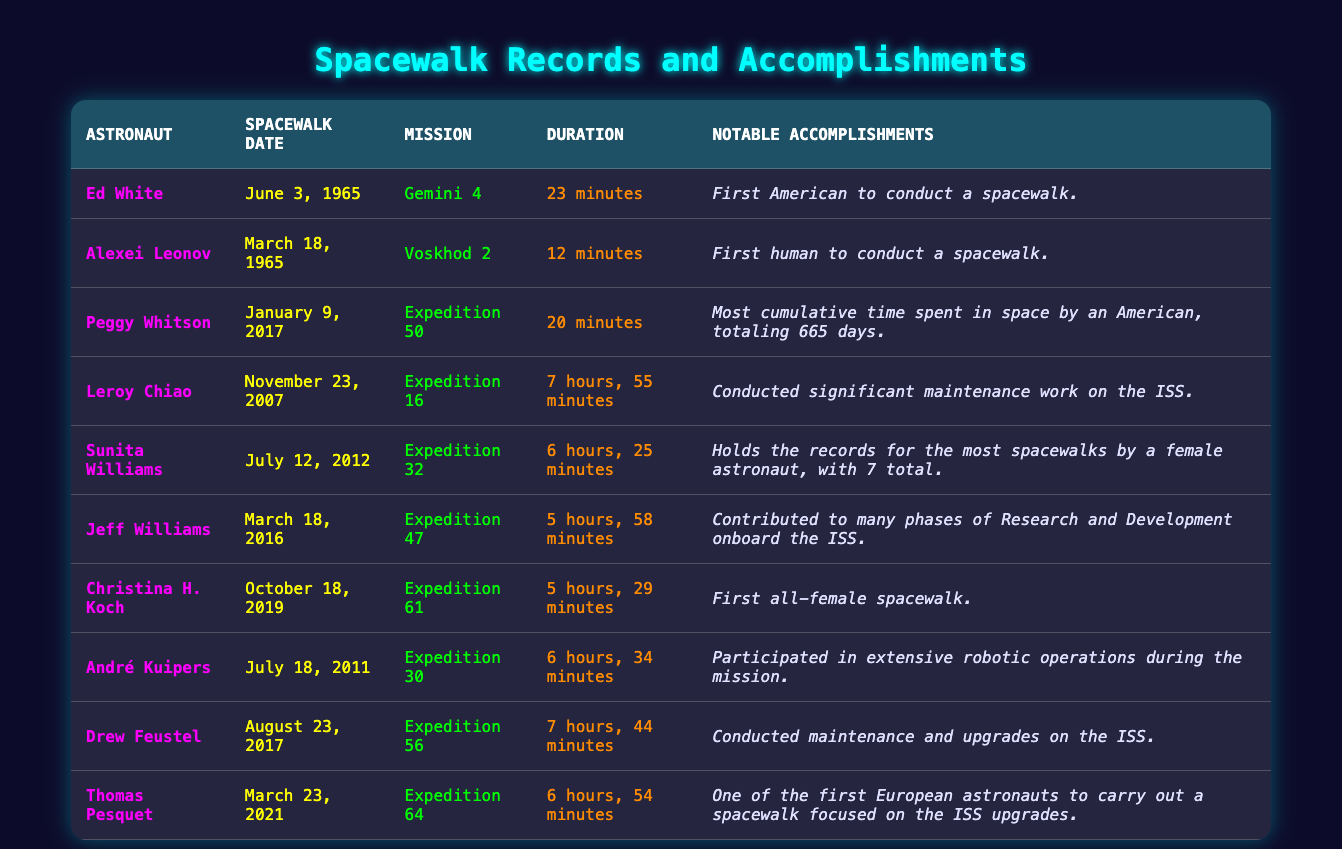What was the duration of Ed White's spacewalk? The table shows that Ed White conducted a spacewalk on June 3, 1965, during the Gemini 4 mission, and the duration of that spacewalk was 23 minutes.
Answer: 23 minutes Who conducted the first human spacewalk? According to the table, Alexei Leonov conducted the first human spacewalk on March 18, 1965, during the Voskhod 2 mission.
Answer: Alexei Leonov How many total hours did Sunita Williams spend on her spacewalks? Sunita Williams conducted a spacewalk lasting 6 hours and 25 minutes. As she holds the record for the most spacewalks by a female astronaut with 7 total, to find the total, we would need additional data on the durations of her other spacewalks, which is not provided in this table. Thus, the information is insufficient to calculate the total.
Answer: Insufficient data Is it true that Christina H. Koch participated in the first all-female spacewalk? The table states that Christina H. Koch's spacewalk on October 18, 2019, was indeed the first all-female spacewalk, confirming that the statement is true.
Answer: True Who has the longest single spacewalk duration listed in the table? By comparing the durations provided, Leroy Chiao’s spacewalk lasted 7 hours and 55 minutes, which is longer than any other listed spacewalk duration.
Answer: Leroy Chiao What is the average duration of the spacewalks conducted by astronauts in the table? To find the average, we first convert all durations to minutes: Ed White (23), Alexei Leonov (12), Peggy Whitson (20), Leroy Chiao (475), Sunita Williams (385), Jeff Williams (358), Christina H. Koch (329), André Kuipers (394), Drew Feustel (464), and Thomas Pesquet (414). Adding these gives a total of 2389 minutes and dividing by 10 (the number of astronauts) gives an average of 238.9 minutes.
Answer: 238.9 minutes Which mission had the shortest spacewalk duration? Looking through the table, Alexei Leonov conducted a spacewalk during the Voskhod 2 mission lasting only 12 minutes, which is the shortest listed duration.
Answer: Voskhod 2 How many astronauts participated in spacewalks longer than 6 hours? The table lists astronauts who completed spacewalks longer than 6 hours: Leroy Chiao (7 hours, 55 minutes), Sunita Williams (6 hours, 25 minutes), Drew Feustel (7 hours, 44 minutes), and André Kuipers (6 hours, 34 minutes). This totals to 4 astronauts.
Answer: 4 astronauts Was Peggy Whitson’s spacewalk notable for spending cumulative time in space? The table indicates that Peggy Whitson’s spacewalk was not just about the duration but is notable for her record of the most cumulative time spent in space as an American, which totals 665 days, showing her accomplishment extends beyond a single spacewalk.
Answer: Yes 